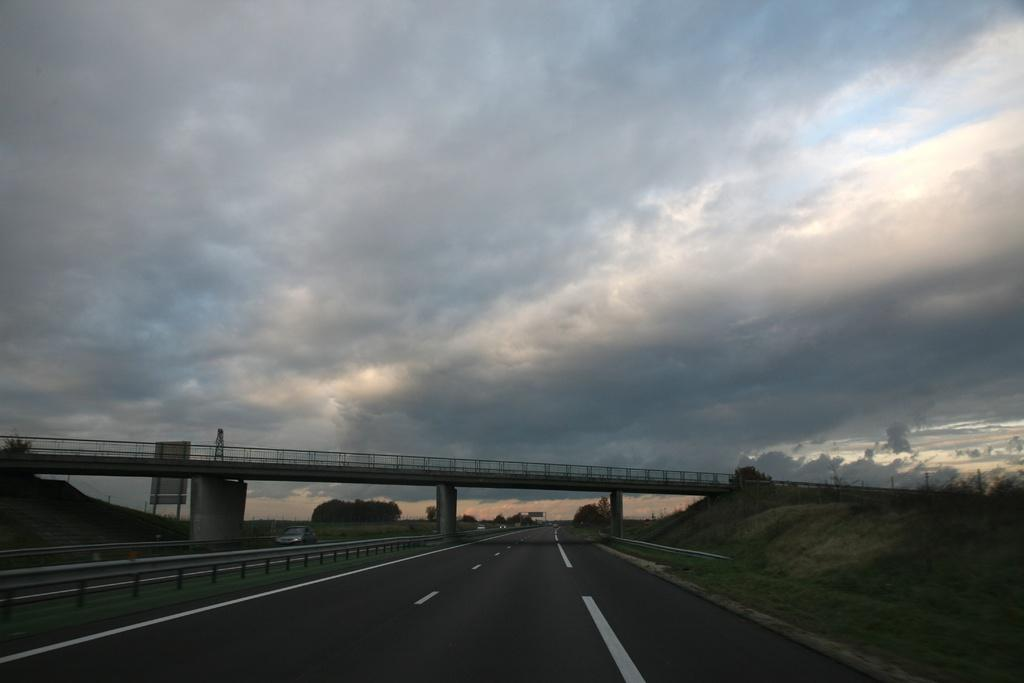What is the main structure in the center of the image? There is a flyover in the center of the image. What is located at the bottom of the image? There is a road at the bottom of the image. What can be seen in the background of the image? There are trees and the sky visible in the background of the image. What is the condition of the sky in the image? The sky has clouds in it. What type of quince is being blown by the wind in the image? There is no quince present in the image, and therefore no such activity can be observed. How does the mind of the flyover in the image work? The flyover is an inanimate object and does not have a mind, so this question cannot be answered. 